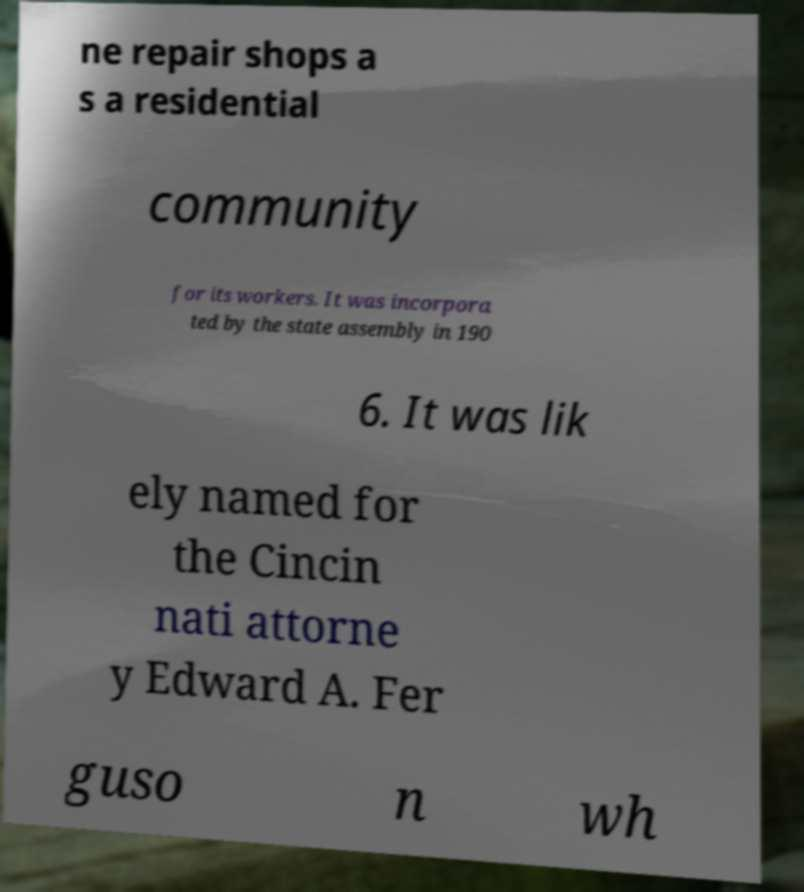Can you accurately transcribe the text from the provided image for me? ne repair shops a s a residential community for its workers. It was incorpora ted by the state assembly in 190 6. It was lik ely named for the Cincin nati attorne y Edward A. Fer guso n wh 